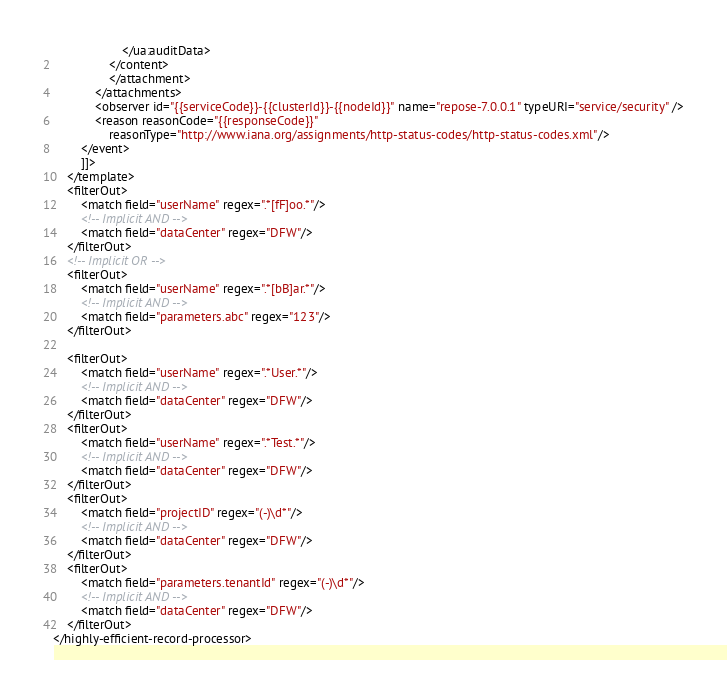<code> <loc_0><loc_0><loc_500><loc_500><_XML_>                    </ua:auditData>
                </content>
                </attachment>
            </attachments>
            <observer id="{{serviceCode}}-{{clusterId}}-{{nodeId}}" name="repose-7.0.0.1" typeURI="service/security" />
            <reason reasonCode="{{responseCode}}"
                reasonType="http://www.iana.org/assignments/http-status-codes/http-status-codes.xml"/>
        </event>
        ]]>
    </template>
    <filterOut>
        <match field="userName" regex=".*[fF]oo.*"/>
        <!-- Implicit AND -->
        <match field="dataCenter" regex="DFW"/>
    </filterOut>
    <!-- Implicit OR -->
    <filterOut>
        <match field="userName" regex=".*[bB]ar.*"/>
        <!-- Implicit AND -->
        <match field="parameters.abc" regex="123"/>
    </filterOut>

    <filterOut>
        <match field="userName" regex=".*User.*"/>
        <!-- Implicit AND -->
        <match field="dataCenter" regex="DFW"/>
    </filterOut>
    <filterOut>
        <match field="userName" regex=".*Test.*"/>
        <!-- Implicit AND -->
        <match field="dataCenter" regex="DFW"/>
    </filterOut>
    <filterOut>
        <match field="projectID" regex="(-)\d*"/>
        <!-- Implicit AND -->
        <match field="dataCenter" regex="DFW"/>
    </filterOut>
    <filterOut>
        <match field="parameters.tenantId" regex="(-)\d*"/>
        <!-- Implicit AND -->
        <match field="dataCenter" regex="DFW"/>
    </filterOut>
</highly-efficient-record-processor>
</code> 